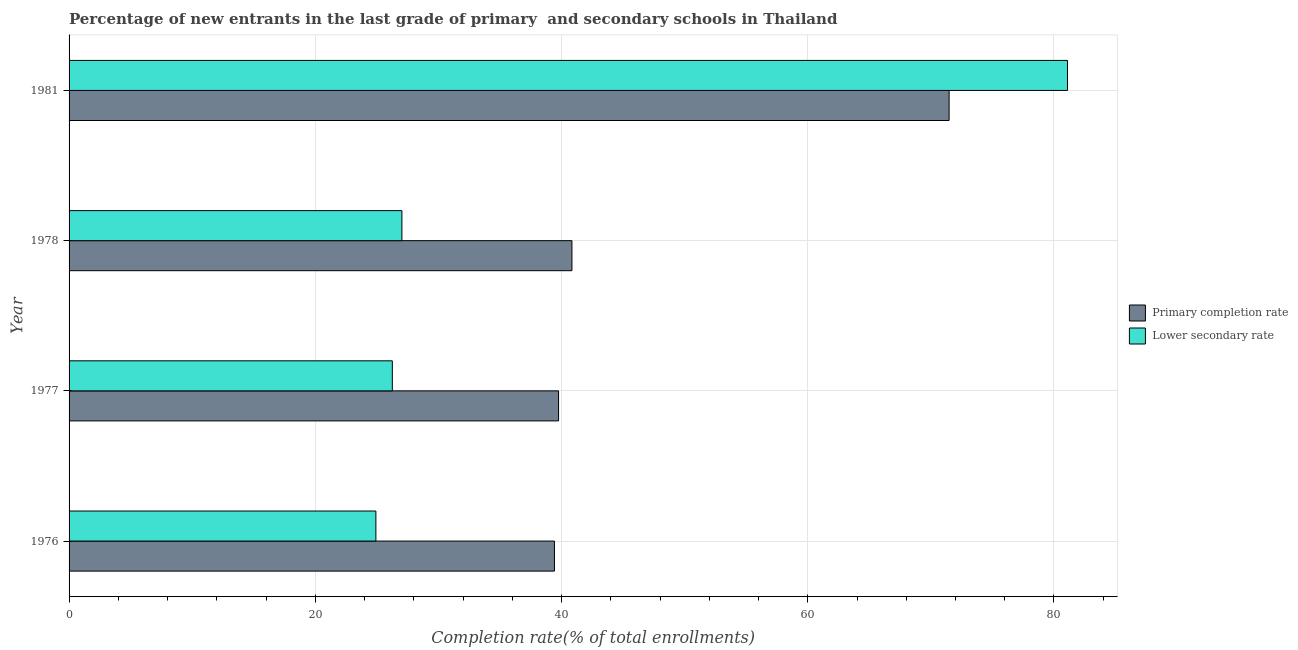How many groups of bars are there?
Your answer should be compact. 4. What is the label of the 4th group of bars from the top?
Offer a terse response. 1976. What is the completion rate in primary schools in 1978?
Make the answer very short. 40.85. Across all years, what is the maximum completion rate in primary schools?
Ensure brevity in your answer.  71.48. Across all years, what is the minimum completion rate in primary schools?
Offer a very short reply. 39.42. In which year was the completion rate in primary schools minimum?
Offer a very short reply. 1976. What is the total completion rate in primary schools in the graph?
Offer a very short reply. 191.51. What is the difference between the completion rate in secondary schools in 1976 and that in 1981?
Your response must be concise. -56.18. What is the difference between the completion rate in secondary schools in 1981 and the completion rate in primary schools in 1976?
Offer a very short reply. 41.67. What is the average completion rate in primary schools per year?
Your response must be concise. 47.88. In the year 1977, what is the difference between the completion rate in secondary schools and completion rate in primary schools?
Keep it short and to the point. -13.5. What is the ratio of the completion rate in secondary schools in 1976 to that in 1981?
Provide a succinct answer. 0.31. What is the difference between the highest and the second highest completion rate in primary schools?
Give a very brief answer. 30.64. What is the difference between the highest and the lowest completion rate in primary schools?
Give a very brief answer. 32.06. In how many years, is the completion rate in secondary schools greater than the average completion rate in secondary schools taken over all years?
Your answer should be compact. 1. What does the 1st bar from the top in 1981 represents?
Your response must be concise. Lower secondary rate. What does the 2nd bar from the bottom in 1981 represents?
Offer a terse response. Lower secondary rate. Are the values on the major ticks of X-axis written in scientific E-notation?
Your response must be concise. No. How many legend labels are there?
Offer a very short reply. 2. How are the legend labels stacked?
Provide a short and direct response. Vertical. What is the title of the graph?
Your answer should be compact. Percentage of new entrants in the last grade of primary  and secondary schools in Thailand. What is the label or title of the X-axis?
Your response must be concise. Completion rate(% of total enrollments). What is the label or title of the Y-axis?
Keep it short and to the point. Year. What is the Completion rate(% of total enrollments) in Primary completion rate in 1976?
Make the answer very short. 39.42. What is the Completion rate(% of total enrollments) in Lower secondary rate in 1976?
Ensure brevity in your answer.  24.92. What is the Completion rate(% of total enrollments) in Primary completion rate in 1977?
Offer a very short reply. 39.76. What is the Completion rate(% of total enrollments) in Lower secondary rate in 1977?
Provide a succinct answer. 26.26. What is the Completion rate(% of total enrollments) of Primary completion rate in 1978?
Provide a short and direct response. 40.85. What is the Completion rate(% of total enrollments) of Lower secondary rate in 1978?
Keep it short and to the point. 27.03. What is the Completion rate(% of total enrollments) of Primary completion rate in 1981?
Make the answer very short. 71.48. What is the Completion rate(% of total enrollments) in Lower secondary rate in 1981?
Your response must be concise. 81.1. Across all years, what is the maximum Completion rate(% of total enrollments) in Primary completion rate?
Your answer should be very brief. 71.48. Across all years, what is the maximum Completion rate(% of total enrollments) of Lower secondary rate?
Offer a terse response. 81.1. Across all years, what is the minimum Completion rate(% of total enrollments) in Primary completion rate?
Your response must be concise. 39.42. Across all years, what is the minimum Completion rate(% of total enrollments) of Lower secondary rate?
Offer a very short reply. 24.92. What is the total Completion rate(% of total enrollments) of Primary completion rate in the graph?
Keep it short and to the point. 191.51. What is the total Completion rate(% of total enrollments) in Lower secondary rate in the graph?
Provide a short and direct response. 159.31. What is the difference between the Completion rate(% of total enrollments) of Primary completion rate in 1976 and that in 1977?
Offer a terse response. -0.34. What is the difference between the Completion rate(% of total enrollments) in Lower secondary rate in 1976 and that in 1977?
Ensure brevity in your answer.  -1.34. What is the difference between the Completion rate(% of total enrollments) in Primary completion rate in 1976 and that in 1978?
Make the answer very short. -1.42. What is the difference between the Completion rate(% of total enrollments) of Lower secondary rate in 1976 and that in 1978?
Ensure brevity in your answer.  -2.11. What is the difference between the Completion rate(% of total enrollments) of Primary completion rate in 1976 and that in 1981?
Your answer should be compact. -32.06. What is the difference between the Completion rate(% of total enrollments) in Lower secondary rate in 1976 and that in 1981?
Provide a succinct answer. -56.18. What is the difference between the Completion rate(% of total enrollments) in Primary completion rate in 1977 and that in 1978?
Give a very brief answer. -1.09. What is the difference between the Completion rate(% of total enrollments) of Lower secondary rate in 1977 and that in 1978?
Offer a very short reply. -0.78. What is the difference between the Completion rate(% of total enrollments) of Primary completion rate in 1977 and that in 1981?
Your response must be concise. -31.72. What is the difference between the Completion rate(% of total enrollments) in Lower secondary rate in 1977 and that in 1981?
Keep it short and to the point. -54.84. What is the difference between the Completion rate(% of total enrollments) of Primary completion rate in 1978 and that in 1981?
Your answer should be very brief. -30.64. What is the difference between the Completion rate(% of total enrollments) of Lower secondary rate in 1978 and that in 1981?
Make the answer very short. -54.06. What is the difference between the Completion rate(% of total enrollments) in Primary completion rate in 1976 and the Completion rate(% of total enrollments) in Lower secondary rate in 1977?
Make the answer very short. 13.17. What is the difference between the Completion rate(% of total enrollments) in Primary completion rate in 1976 and the Completion rate(% of total enrollments) in Lower secondary rate in 1978?
Your response must be concise. 12.39. What is the difference between the Completion rate(% of total enrollments) of Primary completion rate in 1976 and the Completion rate(% of total enrollments) of Lower secondary rate in 1981?
Ensure brevity in your answer.  -41.67. What is the difference between the Completion rate(% of total enrollments) of Primary completion rate in 1977 and the Completion rate(% of total enrollments) of Lower secondary rate in 1978?
Your answer should be very brief. 12.72. What is the difference between the Completion rate(% of total enrollments) of Primary completion rate in 1977 and the Completion rate(% of total enrollments) of Lower secondary rate in 1981?
Your answer should be very brief. -41.34. What is the difference between the Completion rate(% of total enrollments) in Primary completion rate in 1978 and the Completion rate(% of total enrollments) in Lower secondary rate in 1981?
Provide a short and direct response. -40.25. What is the average Completion rate(% of total enrollments) of Primary completion rate per year?
Provide a short and direct response. 47.88. What is the average Completion rate(% of total enrollments) of Lower secondary rate per year?
Your answer should be compact. 39.83. In the year 1976, what is the difference between the Completion rate(% of total enrollments) of Primary completion rate and Completion rate(% of total enrollments) of Lower secondary rate?
Offer a terse response. 14.5. In the year 1977, what is the difference between the Completion rate(% of total enrollments) in Primary completion rate and Completion rate(% of total enrollments) in Lower secondary rate?
Your answer should be very brief. 13.5. In the year 1978, what is the difference between the Completion rate(% of total enrollments) in Primary completion rate and Completion rate(% of total enrollments) in Lower secondary rate?
Give a very brief answer. 13.81. In the year 1981, what is the difference between the Completion rate(% of total enrollments) of Primary completion rate and Completion rate(% of total enrollments) of Lower secondary rate?
Offer a very short reply. -9.61. What is the ratio of the Completion rate(% of total enrollments) of Lower secondary rate in 1976 to that in 1977?
Your answer should be compact. 0.95. What is the ratio of the Completion rate(% of total enrollments) in Primary completion rate in 1976 to that in 1978?
Offer a very short reply. 0.97. What is the ratio of the Completion rate(% of total enrollments) of Lower secondary rate in 1976 to that in 1978?
Offer a very short reply. 0.92. What is the ratio of the Completion rate(% of total enrollments) of Primary completion rate in 1976 to that in 1981?
Your answer should be very brief. 0.55. What is the ratio of the Completion rate(% of total enrollments) in Lower secondary rate in 1976 to that in 1981?
Your response must be concise. 0.31. What is the ratio of the Completion rate(% of total enrollments) of Primary completion rate in 1977 to that in 1978?
Make the answer very short. 0.97. What is the ratio of the Completion rate(% of total enrollments) of Lower secondary rate in 1977 to that in 1978?
Your response must be concise. 0.97. What is the ratio of the Completion rate(% of total enrollments) in Primary completion rate in 1977 to that in 1981?
Your response must be concise. 0.56. What is the ratio of the Completion rate(% of total enrollments) of Lower secondary rate in 1977 to that in 1981?
Provide a succinct answer. 0.32. What is the ratio of the Completion rate(% of total enrollments) of Lower secondary rate in 1978 to that in 1981?
Provide a short and direct response. 0.33. What is the difference between the highest and the second highest Completion rate(% of total enrollments) of Primary completion rate?
Your answer should be very brief. 30.64. What is the difference between the highest and the second highest Completion rate(% of total enrollments) in Lower secondary rate?
Provide a succinct answer. 54.06. What is the difference between the highest and the lowest Completion rate(% of total enrollments) in Primary completion rate?
Your answer should be compact. 32.06. What is the difference between the highest and the lowest Completion rate(% of total enrollments) in Lower secondary rate?
Give a very brief answer. 56.18. 